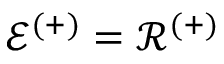<formula> <loc_0><loc_0><loc_500><loc_500>\mathcal { E } ^ { ( + ) } = \mathcal { R } ^ { ( + ) }</formula> 